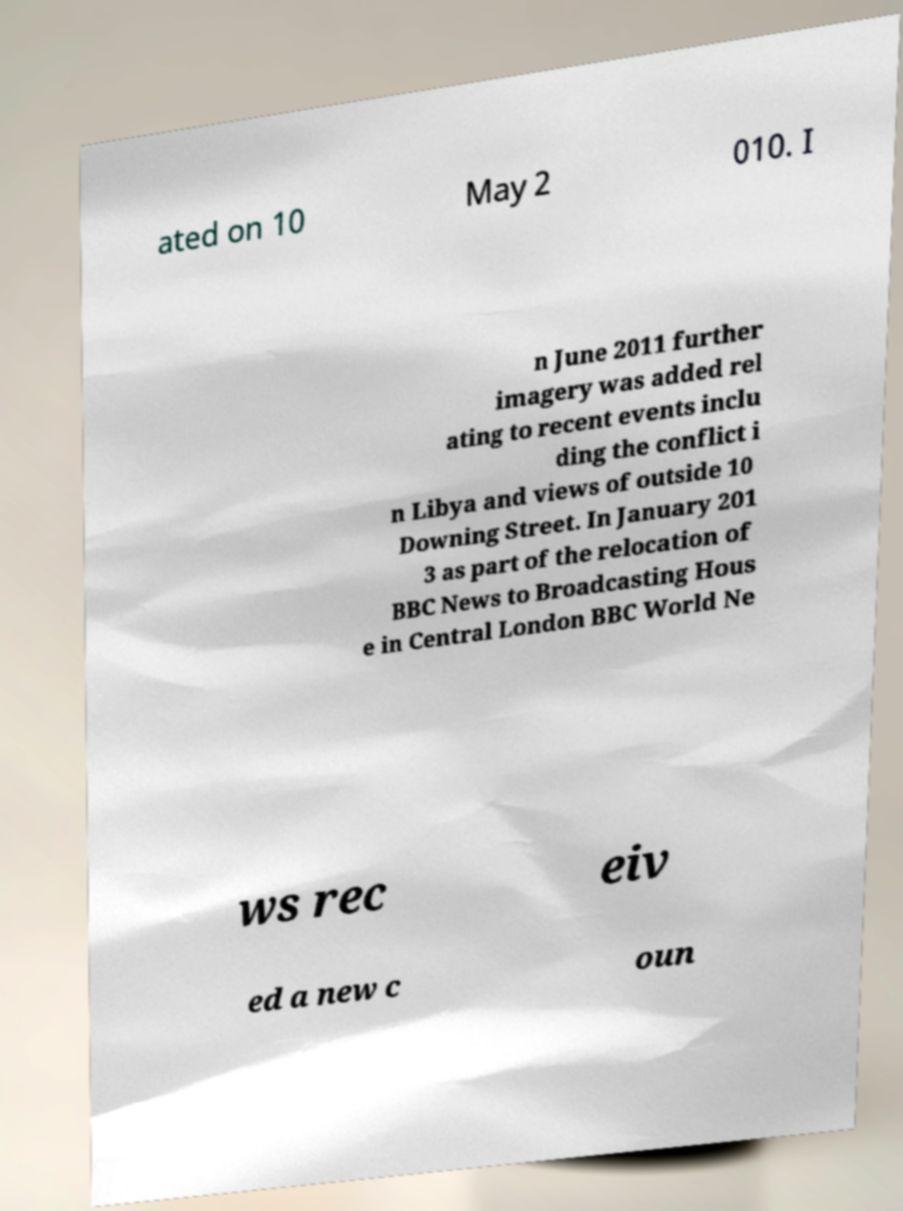I need the written content from this picture converted into text. Can you do that? ated on 10 May 2 010. I n June 2011 further imagery was added rel ating to recent events inclu ding the conflict i n Libya and views of outside 10 Downing Street. In January 201 3 as part of the relocation of BBC News to Broadcasting Hous e in Central London BBC World Ne ws rec eiv ed a new c oun 